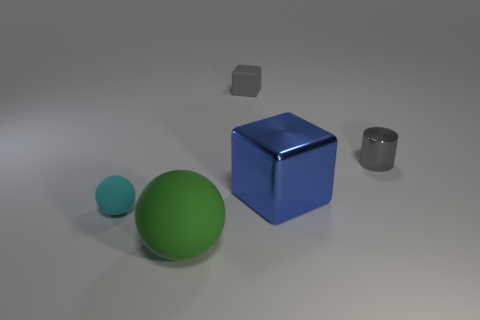Is the material of the block behind the large blue cube the same as the block in front of the gray cylinder?
Your answer should be very brief. No. Are there any blue objects of the same size as the green rubber object?
Your response must be concise. Yes. What is the shape of the thing in front of the rubber object that is to the left of the big thing left of the large blue cube?
Ensure brevity in your answer.  Sphere. Are there more tiny cyan matte spheres that are on the left side of the cyan rubber object than small blocks?
Provide a succinct answer. No. Is there another rubber thing of the same shape as the small gray matte object?
Your answer should be very brief. No. Is the material of the gray cube the same as the big object that is in front of the blue metal block?
Your answer should be compact. Yes. What color is the large rubber sphere?
Keep it short and to the point. Green. What number of large things are in front of the cube to the right of the thing that is behind the small metallic cylinder?
Your response must be concise. 1. There is a large green matte ball; are there any cyan spheres in front of it?
Provide a succinct answer. No. How many objects are made of the same material as the blue cube?
Make the answer very short. 1. 